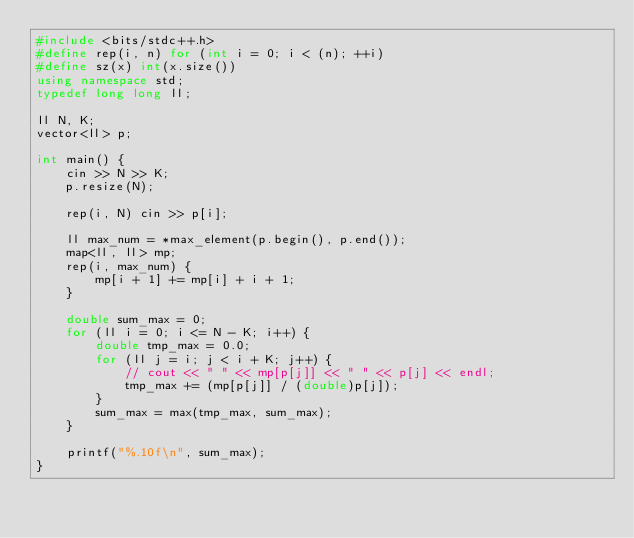Convert code to text. <code><loc_0><loc_0><loc_500><loc_500><_C++_>#include <bits/stdc++.h>
#define rep(i, n) for (int i = 0; i < (n); ++i)
#define sz(x) int(x.size())
using namespace std;
typedef long long ll;

ll N, K;
vector<ll> p;

int main() {
    cin >> N >> K;
    p.resize(N);

    rep(i, N) cin >> p[i];

    ll max_num = *max_element(p.begin(), p.end());
    map<ll, ll> mp;
    rep(i, max_num) {
        mp[i + 1] += mp[i] + i + 1;
    }

    double sum_max = 0;
    for (ll i = 0; i <= N - K; i++) {
        double tmp_max = 0.0;
        for (ll j = i; j < i + K; j++) {
            // cout << " " << mp[p[j]] << " " << p[j] << endl;
            tmp_max += (mp[p[j]] / (double)p[j]);
        }
        sum_max = max(tmp_max, sum_max);
    }

    printf("%.10f\n", sum_max);
}</code> 